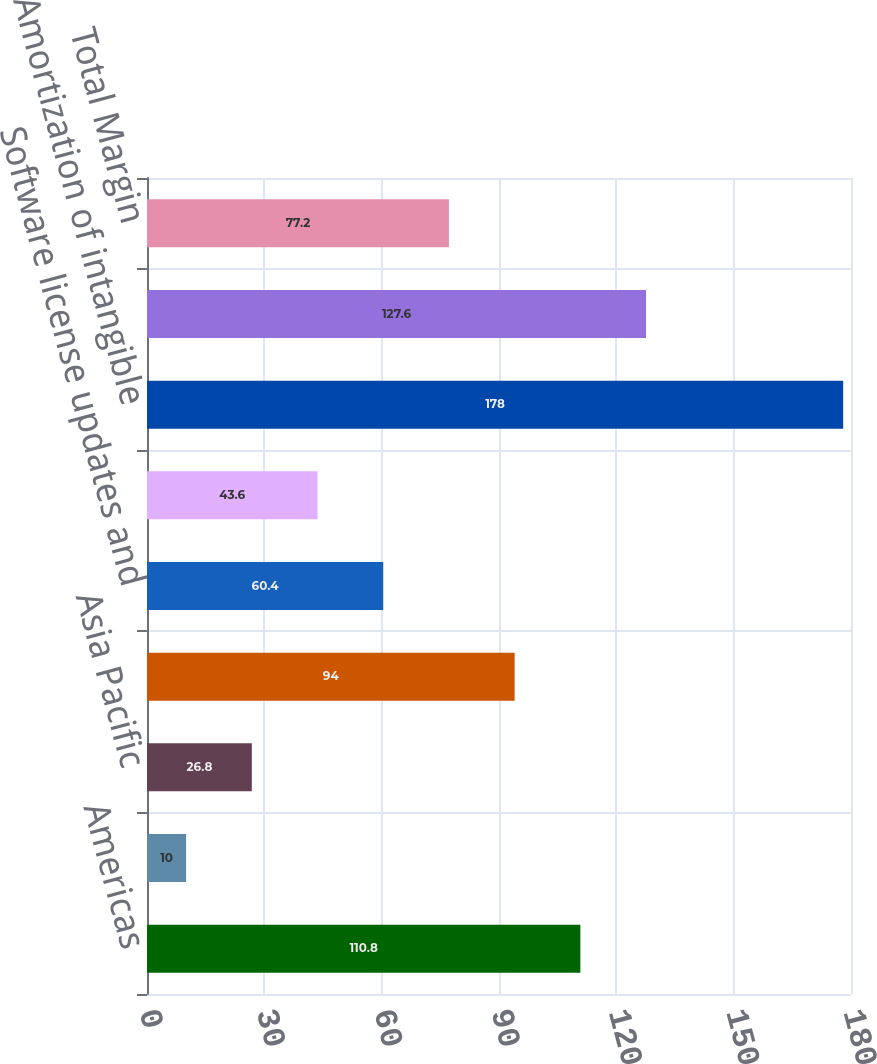Convert chart. <chart><loc_0><loc_0><loc_500><loc_500><bar_chart><fcel>Americas<fcel>EMEA<fcel>Asia Pacific<fcel>Total revenues<fcel>Software license updates and<fcel>Stock-based compensation<fcel>Amortization of intangible<fcel>Total expenses<fcel>Total Margin<nl><fcel>110.8<fcel>10<fcel>26.8<fcel>94<fcel>60.4<fcel>43.6<fcel>178<fcel>127.6<fcel>77.2<nl></chart> 